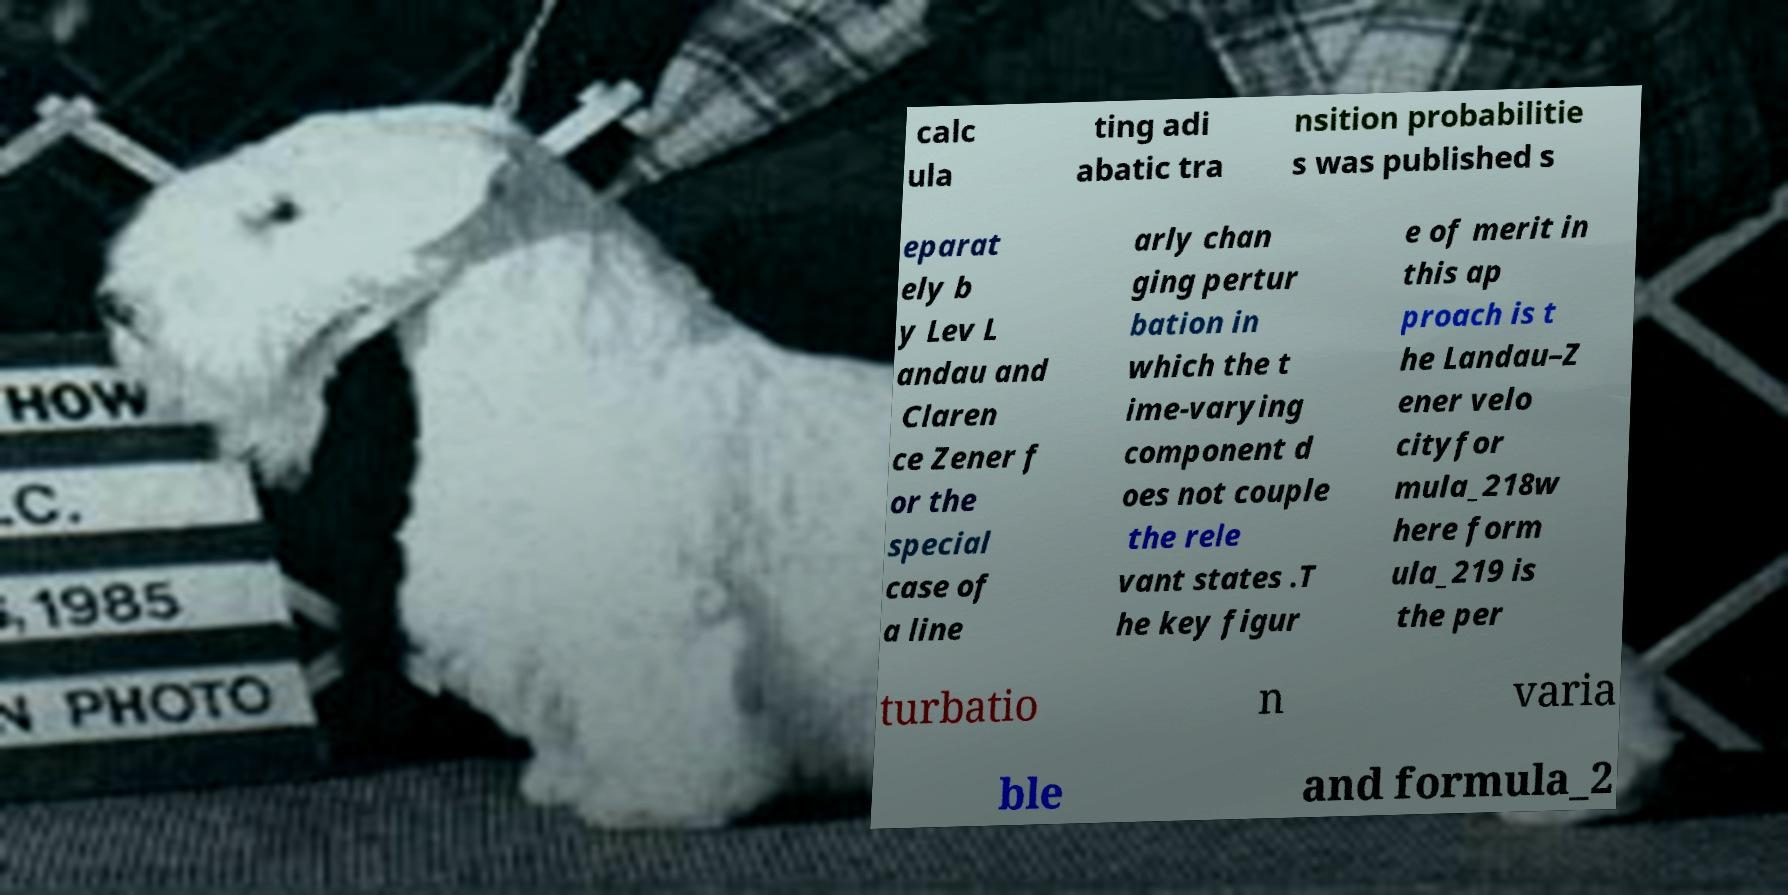For documentation purposes, I need the text within this image transcribed. Could you provide that? calc ula ting adi abatic tra nsition probabilitie s was published s eparat ely b y Lev L andau and Claren ce Zener f or the special case of a line arly chan ging pertur bation in which the t ime-varying component d oes not couple the rele vant states .T he key figur e of merit in this ap proach is t he Landau–Z ener velo cityfor mula_218w here form ula_219 is the per turbatio n varia ble and formula_2 